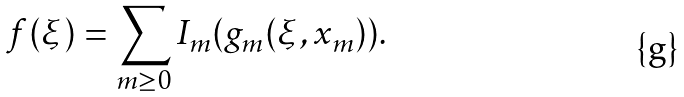Convert formula to latex. <formula><loc_0><loc_0><loc_500><loc_500>f ( \xi ) = \sum _ { m \geq 0 } I _ { m } ( g _ { m } ( \xi , { x } _ { m } ) ) .</formula> 